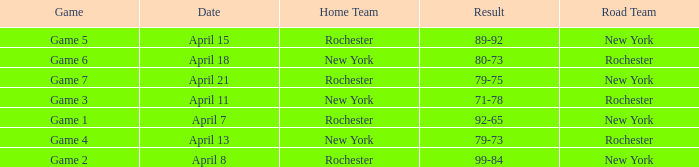Which Road Team has a Home Team of rochester, and a Result of 89-92? New York. 